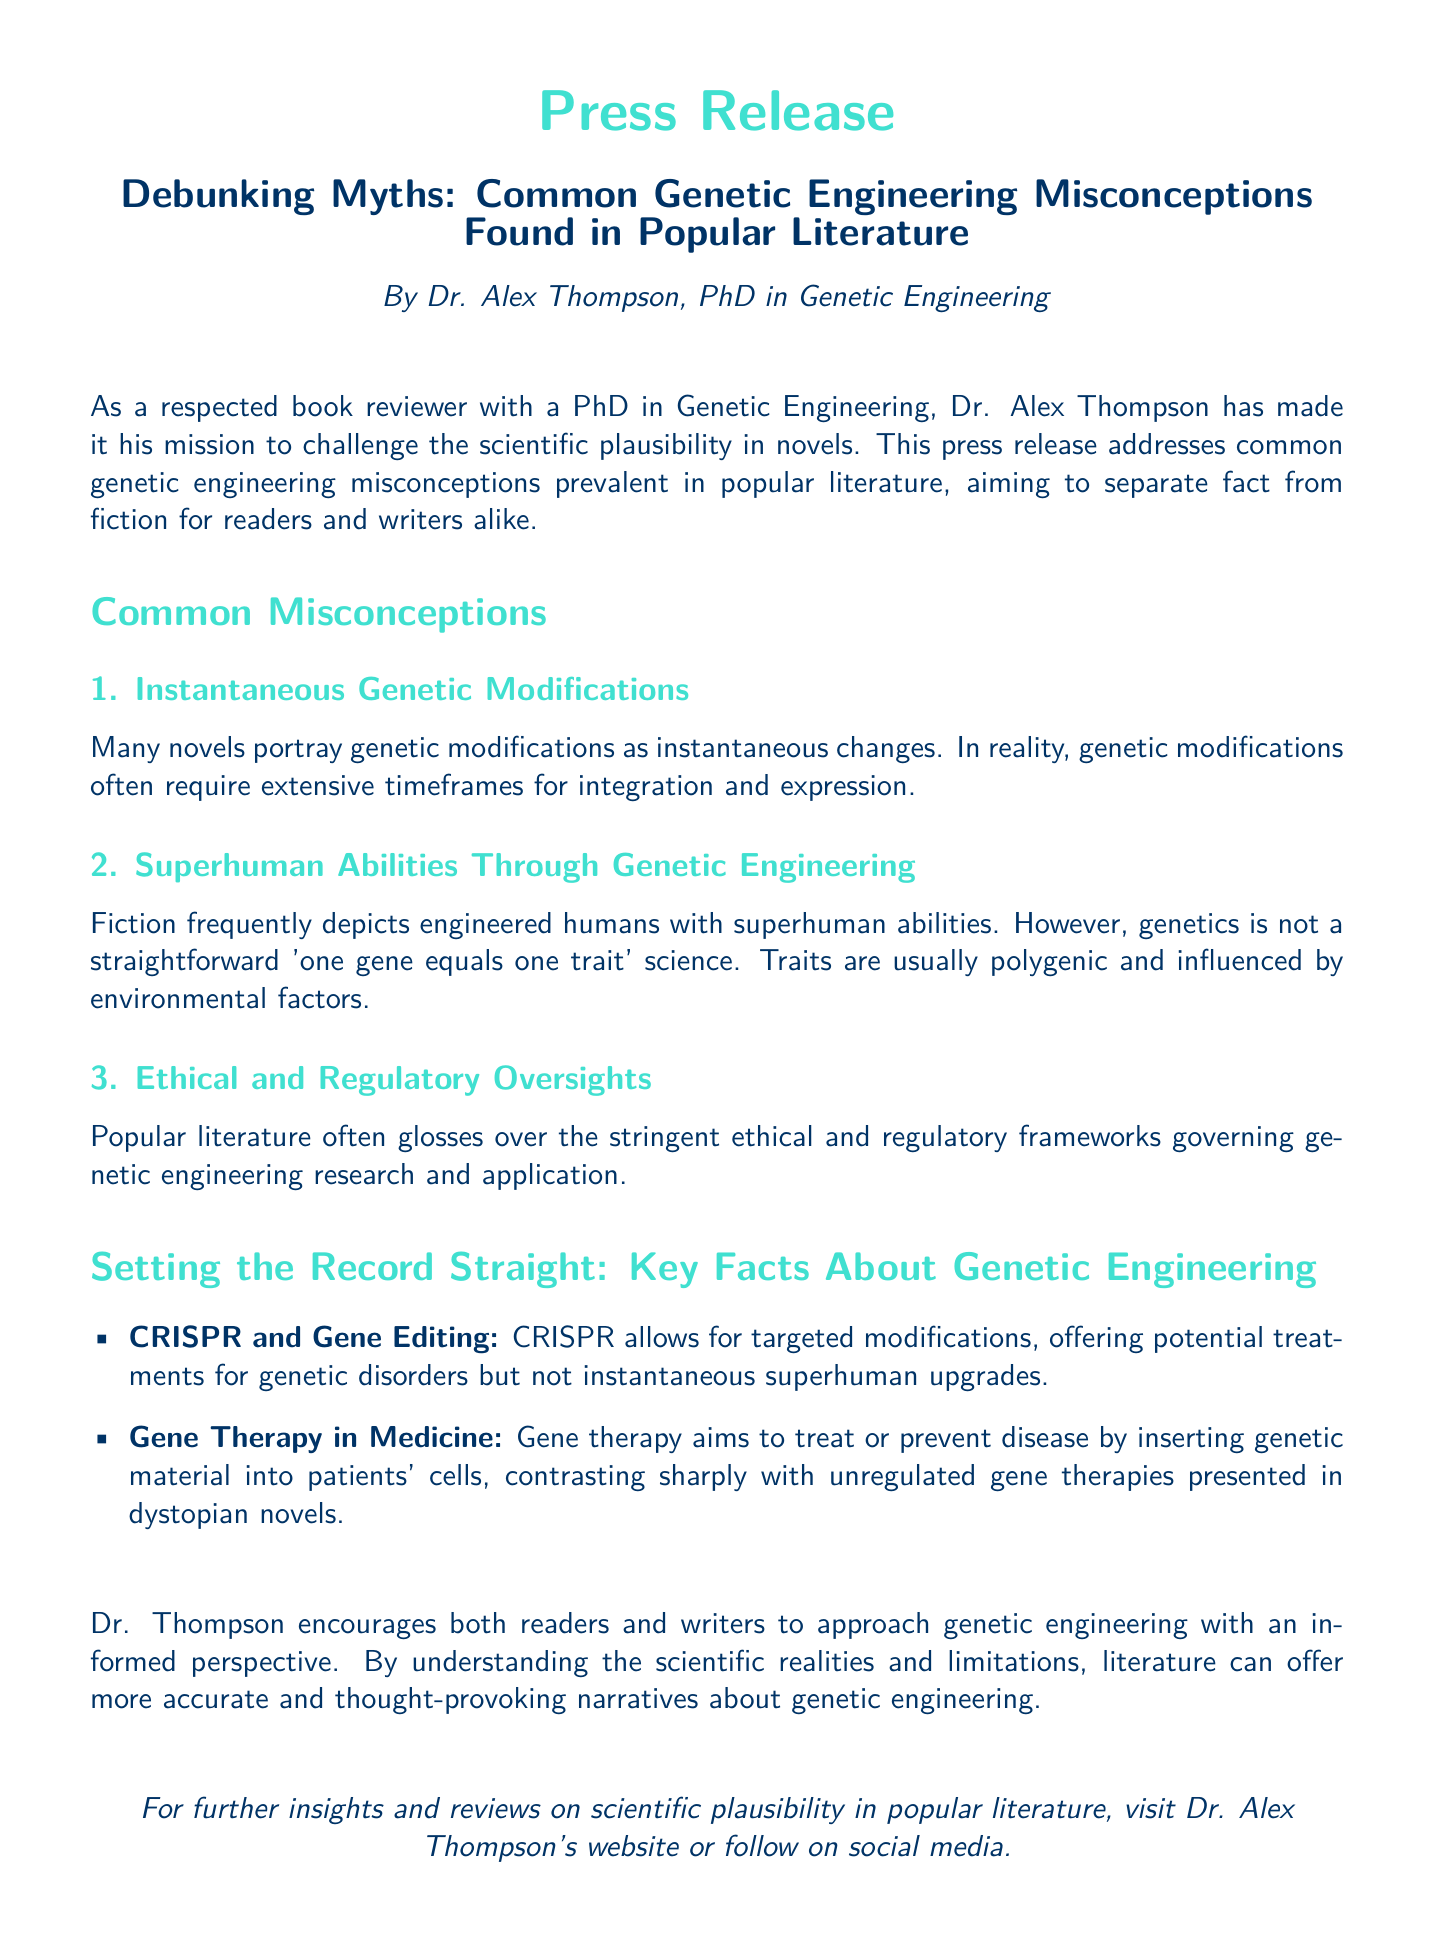What is the title of the press release? The title is prominently displayed in the document and is a key element of the press release.
Answer: Debunking Myths: Common Genetic Engineering Misconceptions Found in Popular Literature Who authored the press release? The author is mentioned at the beginning of the document, providing credibility to the content.
Answer: Dr. Alex Thompson How many common misconceptions are listed in the document? The document explicitly states the number of misconceptions under the "Common Misconceptions" section.
Answer: 3 What genetic technology is mentioned that allows targeted modifications? The document highlights specific genetic technologies that facilitate genetic engineering.
Answer: CRISPR What is one example given of a misconception about genetic engineering? The document lists misconceptions, one of which is particularly focused on the portrayal of how genetic modifications occur in literature.
Answer: Instantaneous Genetic Modifications What does Dr. Thompson encourage readers and writers to have? The document emphasizes a particular attitude or approach that Dr. Thompson advocates for understanding genetic engineering.
Answer: An informed perspective What does gene therapy aim to do? The purpose of gene therapy is clarified in the document, distinguishing it from less regulated representations in literature.
Answer: Treat or prevent disease 